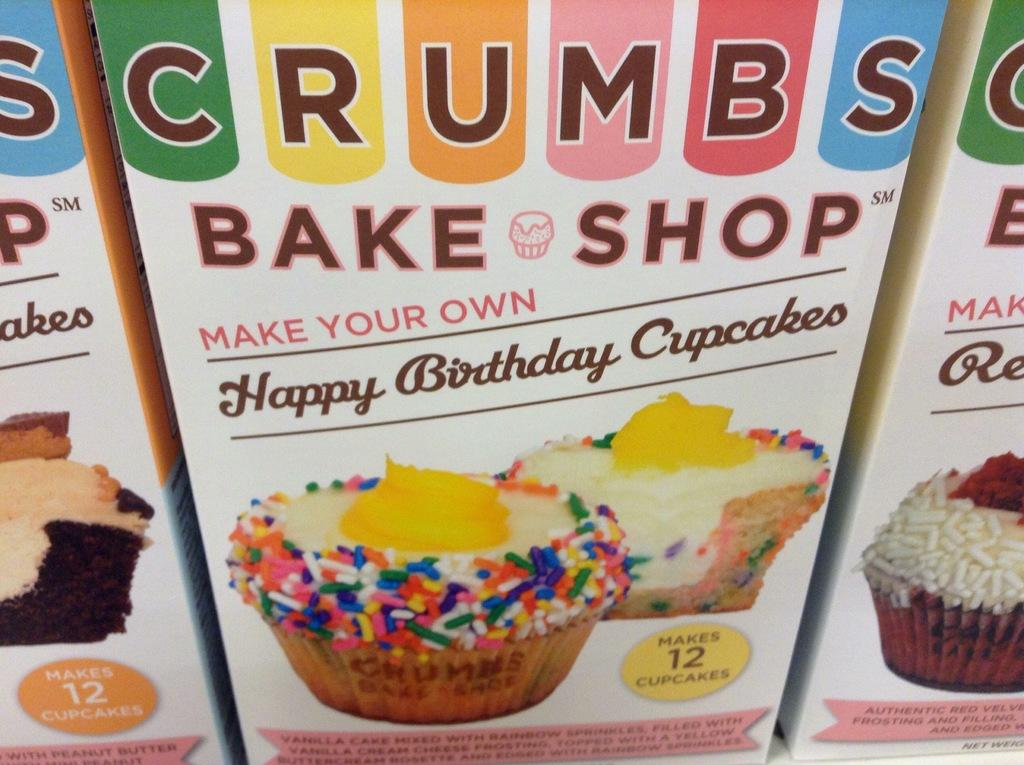What is located in the foreground of the image? There are cupcake boxes in the foreground of the image. What can be seen on the cupcake boxes? The cupcake boxes have images of cupcakes on them. What type of cord is used to secure the cupcake boxes in the image? There is no cord visible in the image; the cupcake boxes are simply placed in the foreground. 